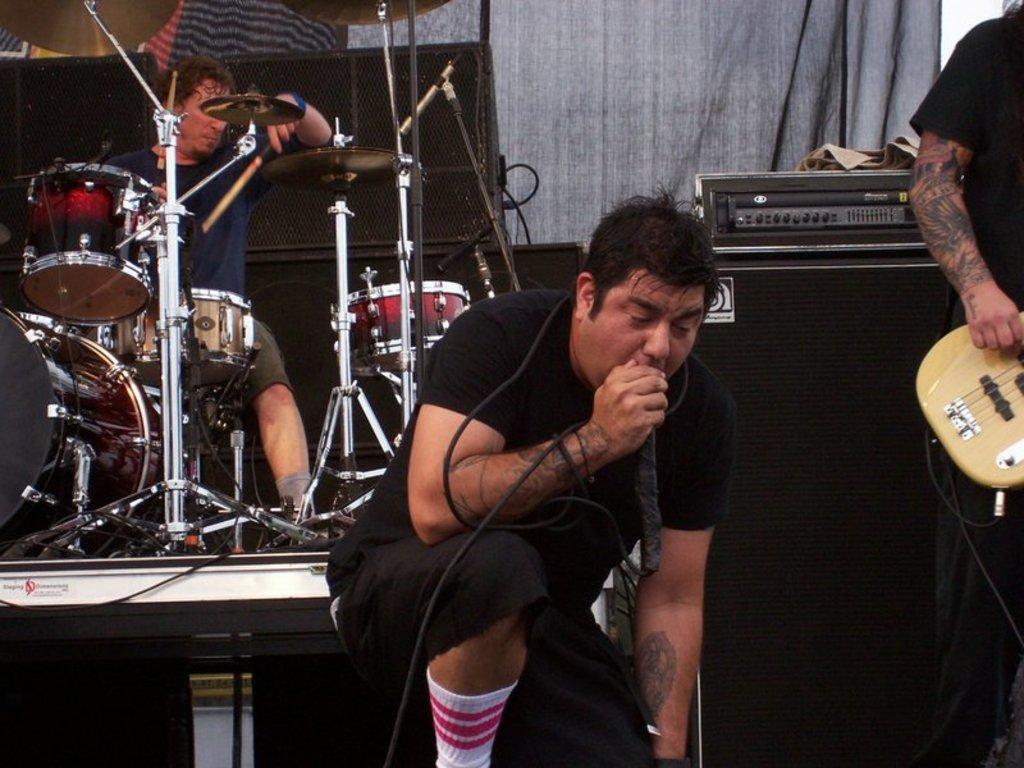In one or two sentences, can you explain what this image depicts? there are two persons one person is sitting and playing drums,another person is sitting and singing in micro phone another person is standing and playing guitar. 